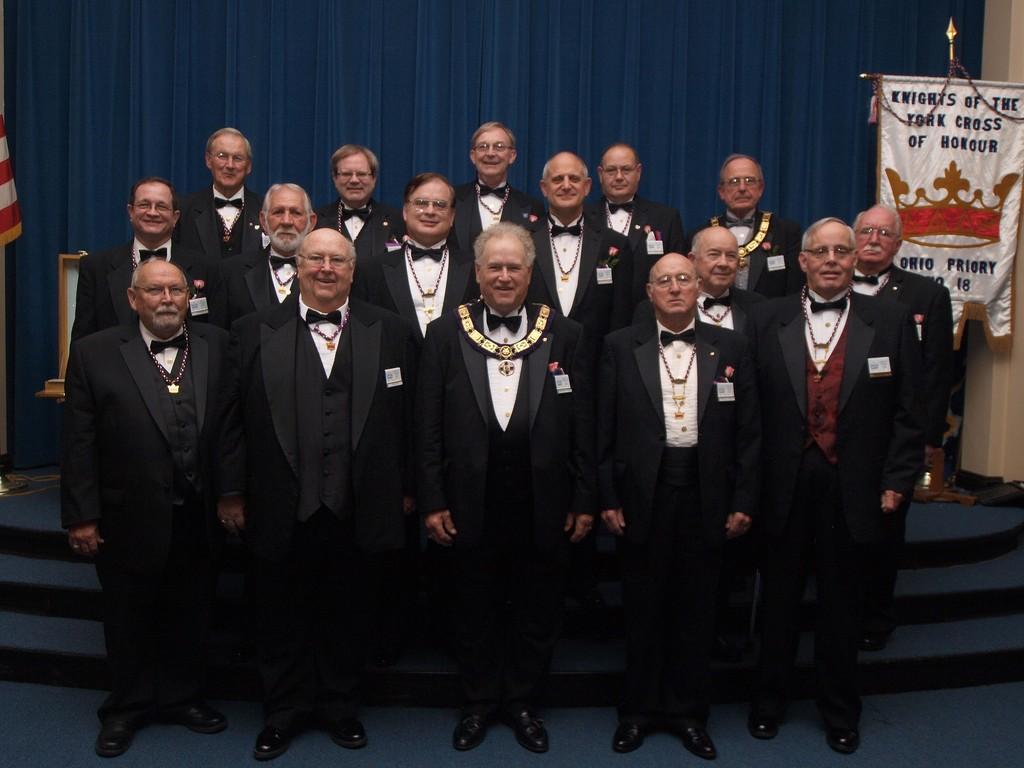How would you summarize this image in a sentence or two? In this picture I can see there are a group of people standing on the stairs and they are wearing blazers and white shirts, few of them are wearing spectacles and there is a blue curtain in the backdrop and there is a banner on to right. 